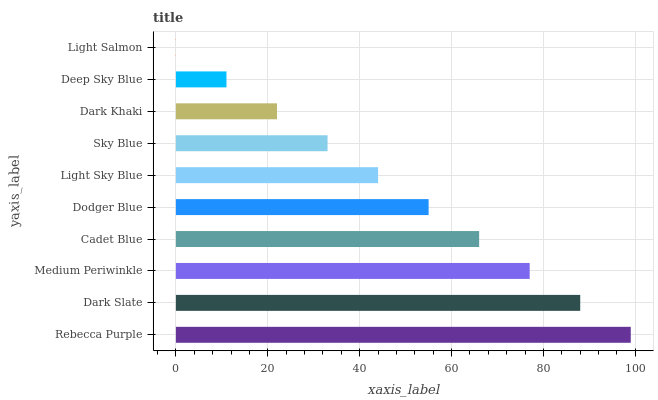Is Light Salmon the minimum?
Answer yes or no. Yes. Is Rebecca Purple the maximum?
Answer yes or no. Yes. Is Dark Slate the minimum?
Answer yes or no. No. Is Dark Slate the maximum?
Answer yes or no. No. Is Rebecca Purple greater than Dark Slate?
Answer yes or no. Yes. Is Dark Slate less than Rebecca Purple?
Answer yes or no. Yes. Is Dark Slate greater than Rebecca Purple?
Answer yes or no. No. Is Rebecca Purple less than Dark Slate?
Answer yes or no. No. Is Dodger Blue the high median?
Answer yes or no. Yes. Is Light Sky Blue the low median?
Answer yes or no. Yes. Is Dark Khaki the high median?
Answer yes or no. No. Is Sky Blue the low median?
Answer yes or no. No. 